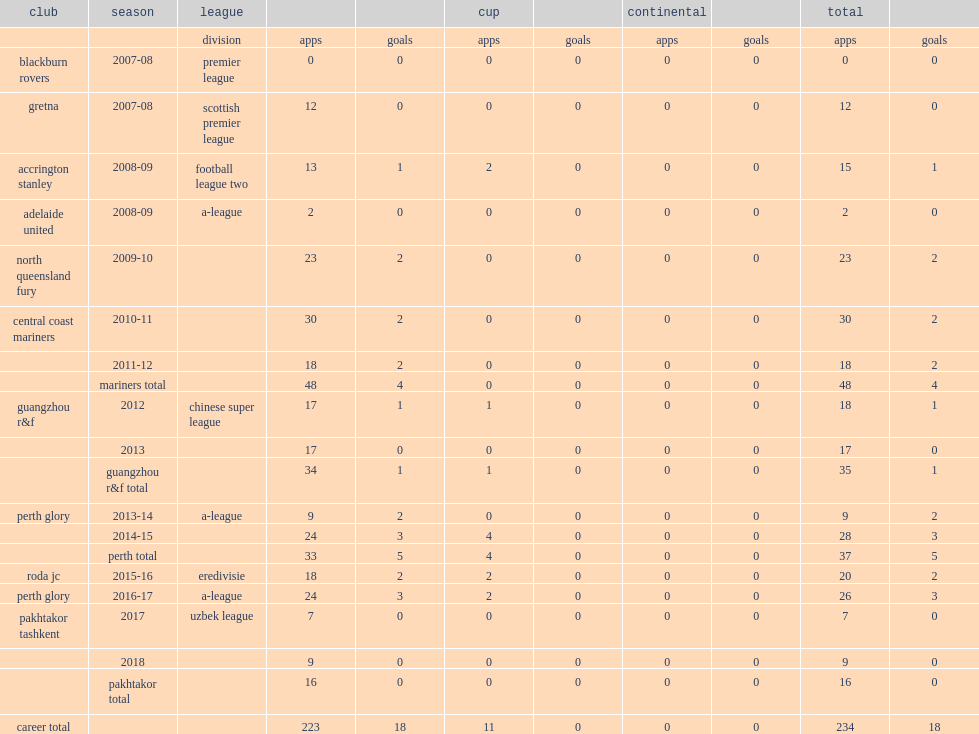In 2017, which club did rostyn griffiths play in the uzbek league? Pakhtakor tashkent. 